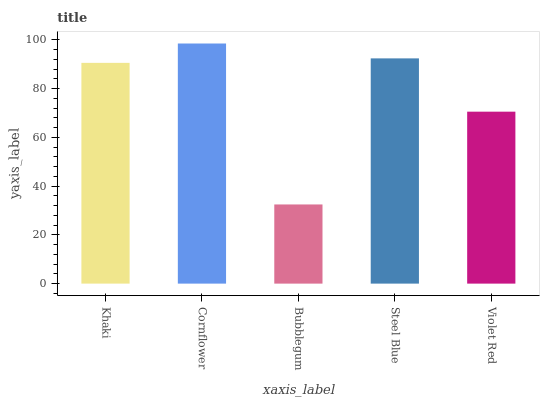Is Bubblegum the minimum?
Answer yes or no. Yes. Is Cornflower the maximum?
Answer yes or no. Yes. Is Cornflower the minimum?
Answer yes or no. No. Is Bubblegum the maximum?
Answer yes or no. No. Is Cornflower greater than Bubblegum?
Answer yes or no. Yes. Is Bubblegum less than Cornflower?
Answer yes or no. Yes. Is Bubblegum greater than Cornflower?
Answer yes or no. No. Is Cornflower less than Bubblegum?
Answer yes or no. No. Is Khaki the high median?
Answer yes or no. Yes. Is Khaki the low median?
Answer yes or no. Yes. Is Violet Red the high median?
Answer yes or no. No. Is Steel Blue the low median?
Answer yes or no. No. 